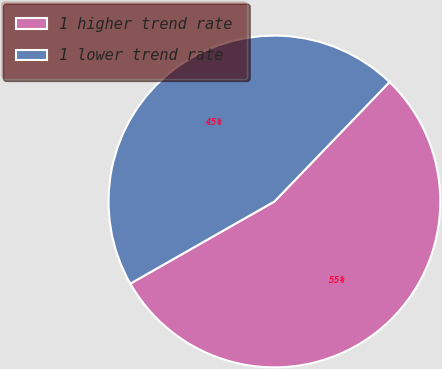Convert chart to OTSL. <chart><loc_0><loc_0><loc_500><loc_500><pie_chart><fcel>1 higher trend rate<fcel>1 lower trend rate<nl><fcel>54.55%<fcel>45.45%<nl></chart> 